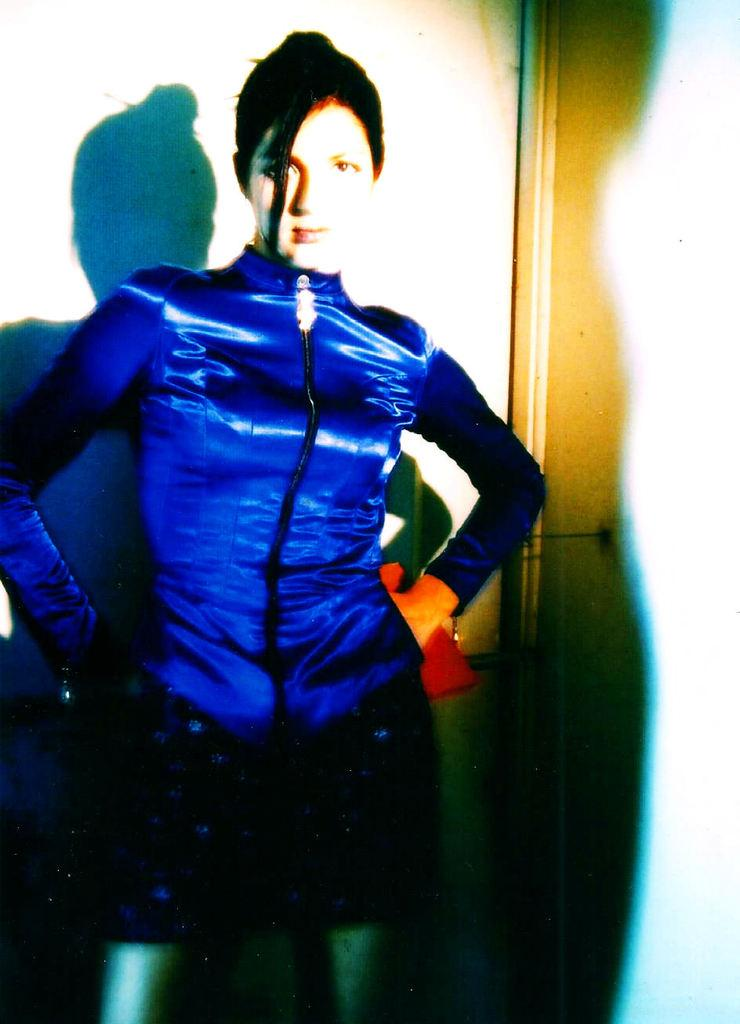What is the main subject of the image? There is a woman standing in the image. What can be seen behind the woman? There is a wall behind the woman. What else is visible in the image related to the woman? The woman's shadow is visible on the wall. What type of drum is the woman playing in the image? There is no drum present in the image; the woman's shadow is visible on the wall. 